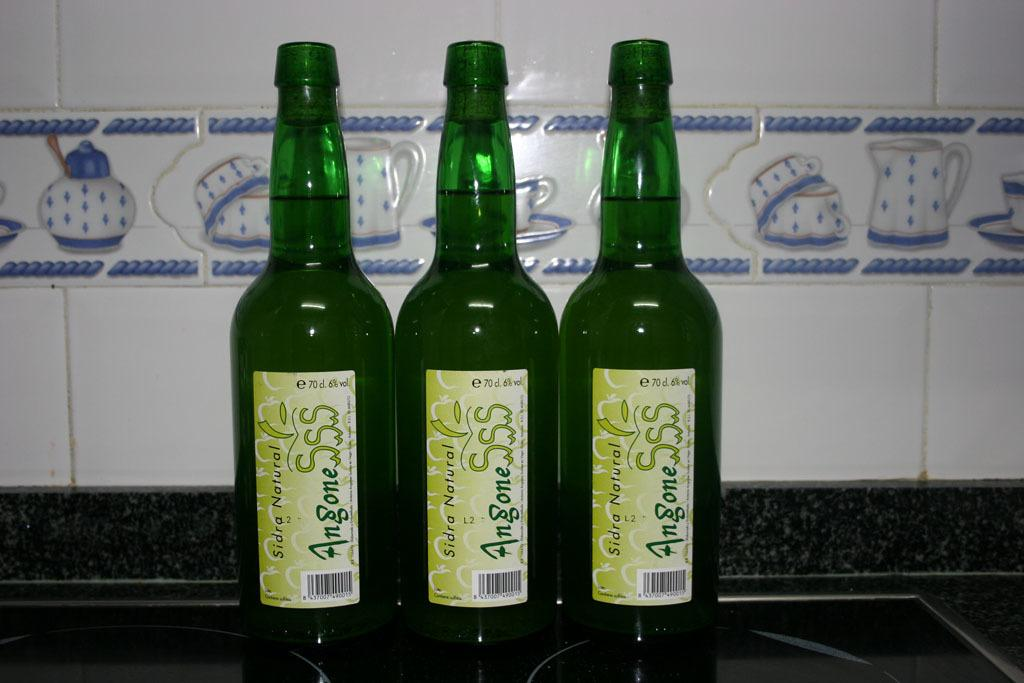<image>
Create a compact narrative representing the image presented. Three green bottles of Angone SSS Sidra Natural 